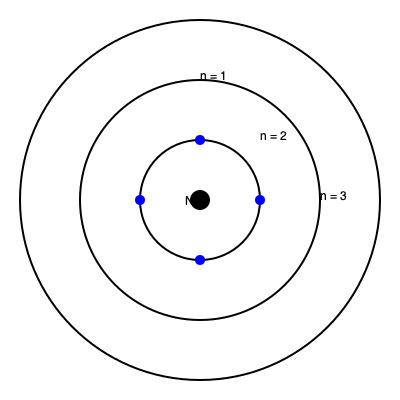Based on the atomic model shown, which statement accurately describes the relationship between electron energy levels and their distance from the nucleus? To answer this question, let's analyze the diagram step-by-step:

1. The diagram shows a simplified model of an atom with three concentric circles representing electron shells.

2. The nucleus (N) is at the center, represented by a small black circle.

3. The shells are labeled with quantum numbers n = 1, n = 2, and n = 3, moving outward from the nucleus.

4. In atomic physics, the quantum number n represents the principal energy level of an electron.

5. The diagram shows that as n increases, the distance from the nucleus also increases.

6. In quantum mechanics, electrons in higher energy levels (larger n) have more energy and are found, on average, farther from the nucleus.

7. This is because electrons in higher energy levels experience less attraction from the nucleus due to increased distance and shielding from inner electrons.

8. The energy of an electron is inversely proportional to its distance from the nucleus, as described by the equation:

   $$ E_n = -\frac{13.6 \text{ eV}}{n^2} $$

   Where $E_n$ is the energy of the electron in the nth energy level, and 13.6 eV is the Rydberg constant for hydrogen.

Therefore, the diagram accurately represents that electrons in higher energy levels (larger n) are found in shells farther from the nucleus.
Answer: Higher energy levels correspond to greater distances from the nucleus. 